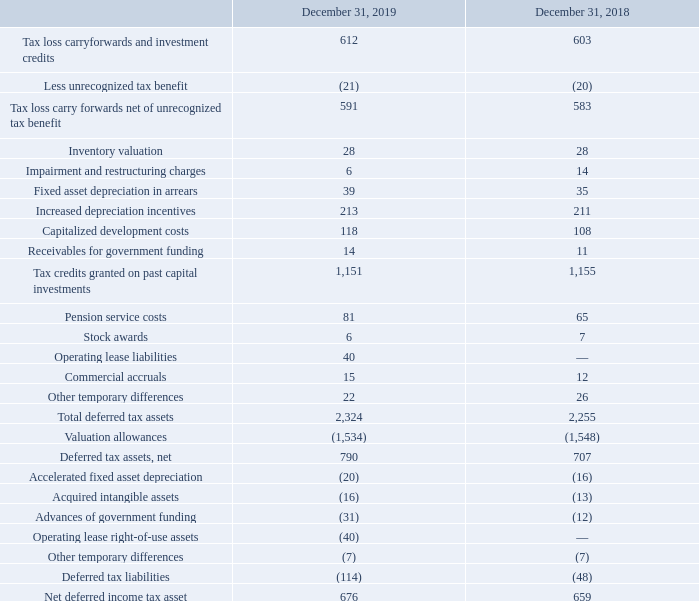For a particular tax-paying component of the Company and within a particular tax jurisdiction, all current deferred tax liabilities and assets are offset and presented as a single amount, similarly to non-current deferred tax liabilities and assets. The Company does not offset deferred tax liabilities and assets attributable to different tax-paying components or to different tax jurisdictions.
The net deferred tax assets are recorded in legal entities which have been historically profitable and are expected to be profitable in the next coming years.
What was the tax loss carryforwards and investment credits in 2019? 612. What adjustments are made by the company for deferred tax asset and liabilities? The company does not offset deferred tax liabilities and assets attributable to different tax-paying components or to different tax jurisdictions. What was the inventory valuation in 2019? 28. What is the increase/ (decrease) in Total deferred tax assets from December 31, 2018 to 2019? 2,324-2,255
Answer: 69. What is the increase/ (decrease) in Deferred tax liabilities from December 31, 2018 to 2019? 114-48
Answer: 66. What is the increase/ (decrease) in Net deferred income tax asset from December 31, 2018 to 2019? 676-659
Answer: 17. 